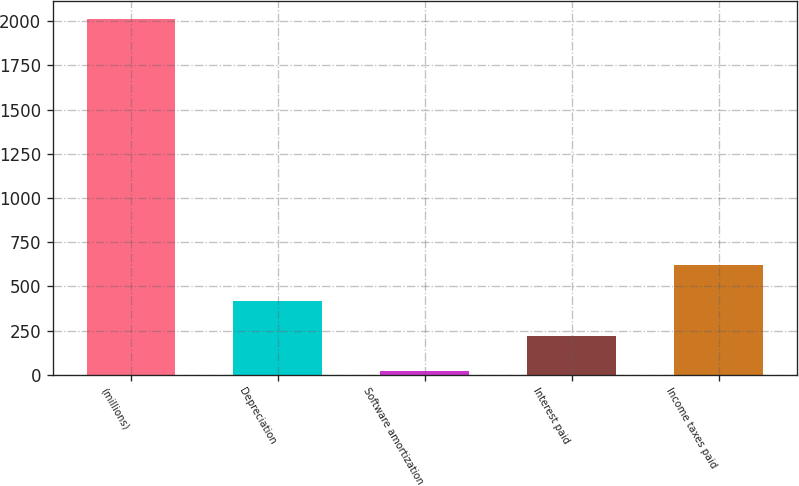Convert chart. <chart><loc_0><loc_0><loc_500><loc_500><bar_chart><fcel>(millions)<fcel>Depreciation<fcel>Software amortization<fcel>Interest paid<fcel>Income taxes paid<nl><fcel>2014<fcel>418.8<fcel>20<fcel>219.4<fcel>618.2<nl></chart> 